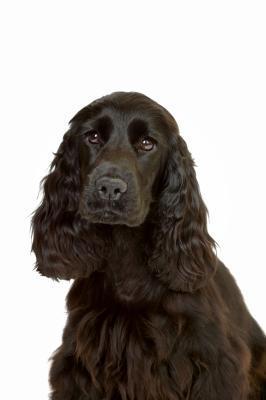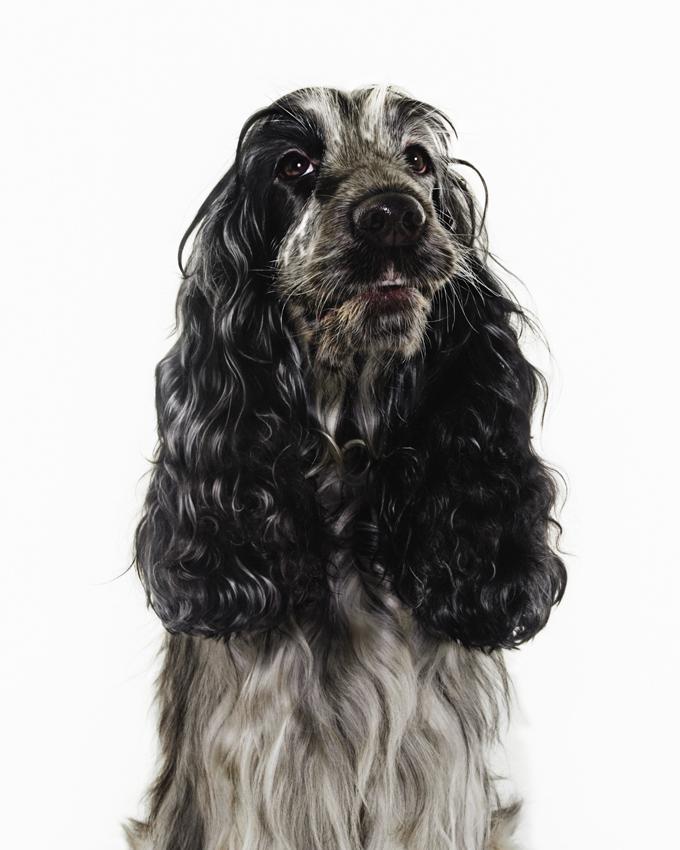The first image is the image on the left, the second image is the image on the right. Considering the images on both sides, is "An image shows exactly one dog colored dark chocolate brown." valid? Answer yes or no. Yes. The first image is the image on the left, the second image is the image on the right. Evaluate the accuracy of this statement regarding the images: "At least one of the dogs has its tongue handing out.". Is it true? Answer yes or no. No. 